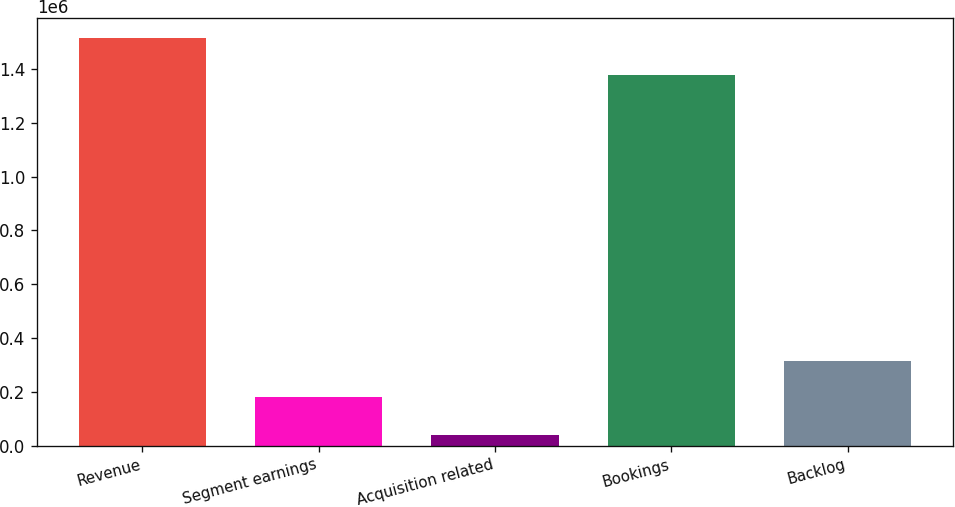<chart> <loc_0><loc_0><loc_500><loc_500><bar_chart><fcel>Revenue<fcel>Segment earnings<fcel>Acquisition related<fcel>Bookings<fcel>Backlog<nl><fcel>1.51373e+06<fcel>180337<fcel>38296<fcel>1.37855e+06<fcel>315518<nl></chart> 